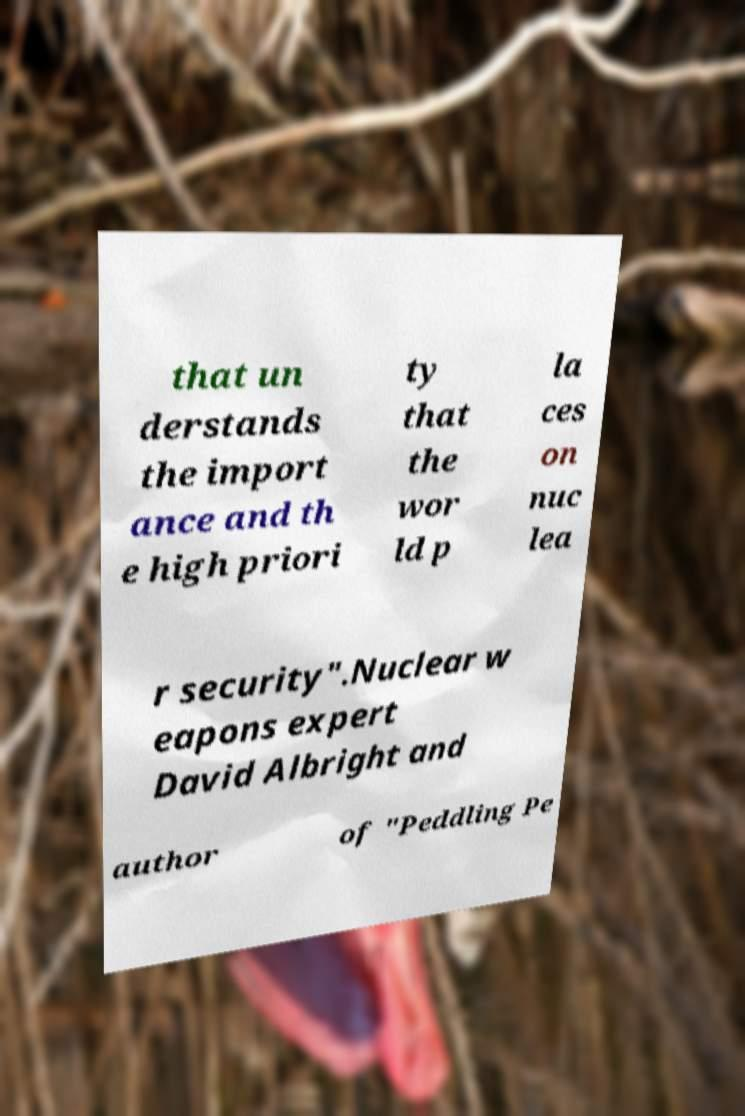There's text embedded in this image that I need extracted. Can you transcribe it verbatim? that un derstands the import ance and th e high priori ty that the wor ld p la ces on nuc lea r security".Nuclear w eapons expert David Albright and author of "Peddling Pe 